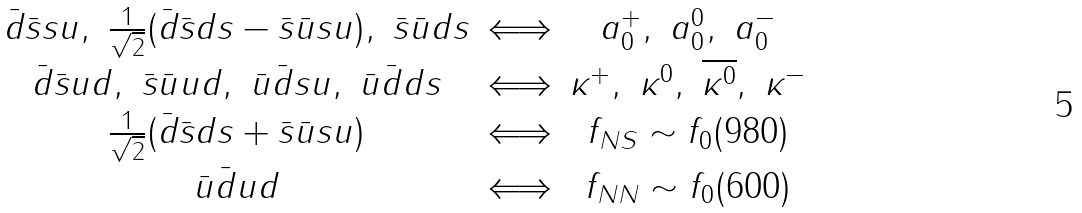<formula> <loc_0><loc_0><loc_500><loc_500>\begin{array} { c c c } \bar { d } \bar { s } s u , \ \frac { 1 } { \sqrt { 2 } } ( \bar { d } \bar { s } d s - \bar { s } \bar { u } s u ) , \ \bar { s } \bar { u } d s & \Longleftrightarrow & a _ { 0 } ^ { + } , \ a _ { 0 } ^ { 0 } , \ a _ { 0 } ^ { - } \\ \bar { d } \bar { s } u d , \ \bar { s } \bar { u } u d , \ \bar { u } \bar { d } s u , \ \bar { u } \bar { d } d s & \Longleftrightarrow & \kappa ^ { + } , \ \kappa ^ { 0 } , \ \overline { \kappa ^ { 0 } } , \ \kappa ^ { - } \\ \frac { 1 } { \sqrt { 2 } } ( \bar { d } \bar { s } d s + \bar { s } \bar { u } s u ) & \Longleftrightarrow & f _ { N S } \sim f _ { 0 } ( 9 8 0 ) \\ \bar { u } \bar { d } u d & \Longleftrightarrow & f _ { N N } \sim f _ { 0 } ( 6 0 0 ) \end{array}</formula> 